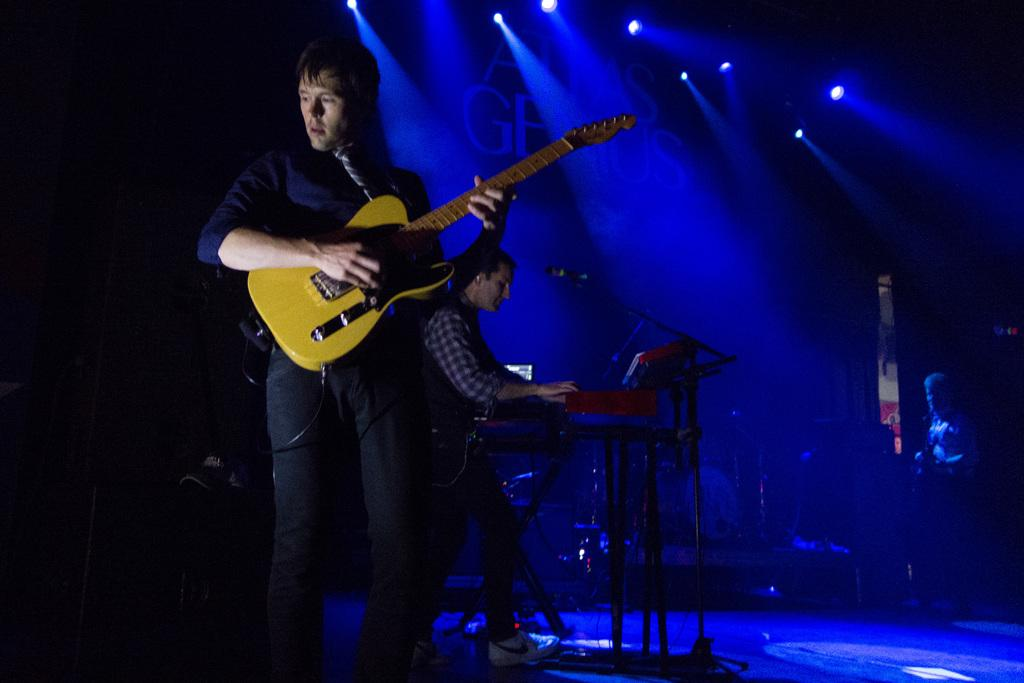What is the man in the image holding? The man is holding a guitar. Can you describe the other person in the image? There is another person in the background of the image, and they are standing in front of a microphone. What can be seen in the background of the image? There are lights visible in the background of the image. What might the man with the guitar be doing in the image? The man with the guitar might be performing or playing music. What type of scarecrow is standing next to the man with the guitar in the image? There is no scarecrow present in the image. What is the lead of the band doing in the image? There is no indication of a band or a lead in the image; it only shows a man holding a guitar and another person with a microphone. 